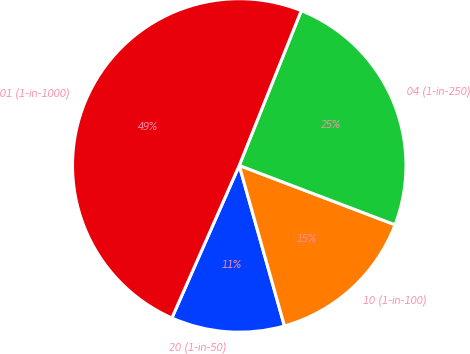<chart> <loc_0><loc_0><loc_500><loc_500><pie_chart><fcel>20 (1-in-50)<fcel>10 (1-in-100)<fcel>04 (1-in-250)<fcel>01 (1-in-1000)<nl><fcel>10.99%<fcel>14.84%<fcel>24.73%<fcel>49.45%<nl></chart> 